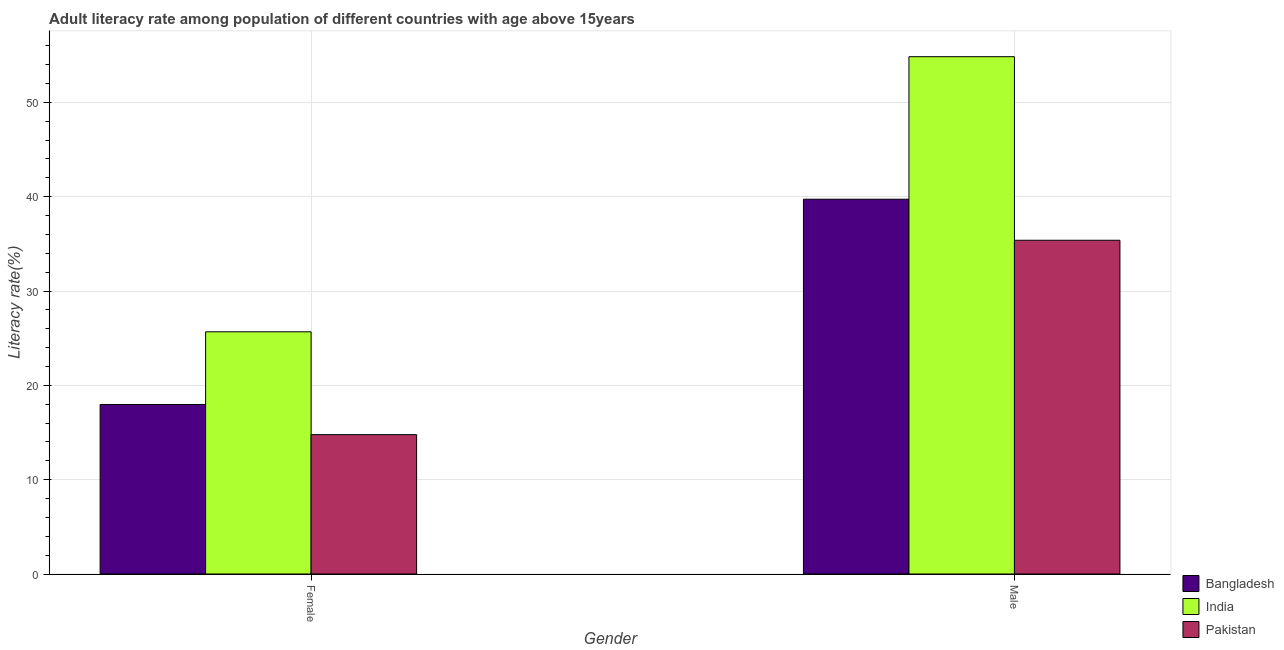How many different coloured bars are there?
Your answer should be compact. 3. How many groups of bars are there?
Your answer should be compact. 2. How many bars are there on the 1st tick from the right?
Your response must be concise. 3. What is the label of the 1st group of bars from the left?
Give a very brief answer. Female. What is the female adult literacy rate in Bangladesh?
Give a very brief answer. 17.97. Across all countries, what is the maximum male adult literacy rate?
Your answer should be compact. 54.84. Across all countries, what is the minimum female adult literacy rate?
Your answer should be very brief. 14.77. In which country was the female adult literacy rate maximum?
Offer a terse response. India. In which country was the female adult literacy rate minimum?
Provide a succinct answer. Pakistan. What is the total female adult literacy rate in the graph?
Your answer should be very brief. 58.42. What is the difference between the male adult literacy rate in Bangladesh and that in Pakistan?
Ensure brevity in your answer.  4.35. What is the difference between the male adult literacy rate in Pakistan and the female adult literacy rate in India?
Your answer should be compact. 9.7. What is the average female adult literacy rate per country?
Give a very brief answer. 19.47. What is the difference between the male adult literacy rate and female adult literacy rate in Bangladesh?
Offer a terse response. 21.76. In how many countries, is the female adult literacy rate greater than 18 %?
Your answer should be very brief. 1. What is the ratio of the female adult literacy rate in Bangladesh to that in Pakistan?
Your answer should be compact. 1.22. In how many countries, is the female adult literacy rate greater than the average female adult literacy rate taken over all countries?
Make the answer very short. 1. What does the 2nd bar from the left in Male represents?
Provide a succinct answer. India. What does the 1st bar from the right in Male represents?
Your answer should be very brief. Pakistan. Are all the bars in the graph horizontal?
Your answer should be very brief. No. Does the graph contain any zero values?
Your answer should be very brief. No. Where does the legend appear in the graph?
Your answer should be very brief. Bottom right. How are the legend labels stacked?
Ensure brevity in your answer.  Vertical. What is the title of the graph?
Provide a short and direct response. Adult literacy rate among population of different countries with age above 15years. Does "Sub-Saharan Africa (all income levels)" appear as one of the legend labels in the graph?
Offer a very short reply. No. What is the label or title of the Y-axis?
Your answer should be very brief. Literacy rate(%). What is the Literacy rate(%) of Bangladesh in Female?
Make the answer very short. 17.97. What is the Literacy rate(%) in India in Female?
Offer a very short reply. 25.68. What is the Literacy rate(%) of Pakistan in Female?
Provide a succinct answer. 14.77. What is the Literacy rate(%) of Bangladesh in Male?
Your answer should be very brief. 39.73. What is the Literacy rate(%) of India in Male?
Your answer should be compact. 54.84. What is the Literacy rate(%) of Pakistan in Male?
Provide a short and direct response. 35.38. Across all Gender, what is the maximum Literacy rate(%) of Bangladesh?
Ensure brevity in your answer.  39.73. Across all Gender, what is the maximum Literacy rate(%) in India?
Keep it short and to the point. 54.84. Across all Gender, what is the maximum Literacy rate(%) of Pakistan?
Offer a very short reply. 35.38. Across all Gender, what is the minimum Literacy rate(%) of Bangladesh?
Offer a very short reply. 17.97. Across all Gender, what is the minimum Literacy rate(%) in India?
Give a very brief answer. 25.68. Across all Gender, what is the minimum Literacy rate(%) of Pakistan?
Provide a short and direct response. 14.77. What is the total Literacy rate(%) of Bangladesh in the graph?
Make the answer very short. 57.7. What is the total Literacy rate(%) of India in the graph?
Offer a very short reply. 80.52. What is the total Literacy rate(%) of Pakistan in the graph?
Give a very brief answer. 50.15. What is the difference between the Literacy rate(%) in Bangladesh in Female and that in Male?
Ensure brevity in your answer.  -21.76. What is the difference between the Literacy rate(%) of India in Female and that in Male?
Keep it short and to the point. -29.16. What is the difference between the Literacy rate(%) of Pakistan in Female and that in Male?
Make the answer very short. -20.61. What is the difference between the Literacy rate(%) in Bangladesh in Female and the Literacy rate(%) in India in Male?
Your answer should be compact. -36.87. What is the difference between the Literacy rate(%) of Bangladesh in Female and the Literacy rate(%) of Pakistan in Male?
Ensure brevity in your answer.  -17.41. What is the difference between the Literacy rate(%) in India in Female and the Literacy rate(%) in Pakistan in Male?
Offer a very short reply. -9.7. What is the average Literacy rate(%) in Bangladesh per Gender?
Your answer should be compact. 28.85. What is the average Literacy rate(%) in India per Gender?
Offer a very short reply. 40.26. What is the average Literacy rate(%) in Pakistan per Gender?
Make the answer very short. 25.08. What is the difference between the Literacy rate(%) of Bangladesh and Literacy rate(%) of India in Female?
Provide a short and direct response. -7.7. What is the difference between the Literacy rate(%) of Bangladesh and Literacy rate(%) of Pakistan in Female?
Your response must be concise. 3.2. What is the difference between the Literacy rate(%) of India and Literacy rate(%) of Pakistan in Female?
Your response must be concise. 10.9. What is the difference between the Literacy rate(%) of Bangladesh and Literacy rate(%) of India in Male?
Provide a short and direct response. -15.11. What is the difference between the Literacy rate(%) in Bangladesh and Literacy rate(%) in Pakistan in Male?
Your response must be concise. 4.35. What is the difference between the Literacy rate(%) in India and Literacy rate(%) in Pakistan in Male?
Keep it short and to the point. 19.46. What is the ratio of the Literacy rate(%) in Bangladesh in Female to that in Male?
Give a very brief answer. 0.45. What is the ratio of the Literacy rate(%) of India in Female to that in Male?
Your answer should be compact. 0.47. What is the ratio of the Literacy rate(%) of Pakistan in Female to that in Male?
Ensure brevity in your answer.  0.42. What is the difference between the highest and the second highest Literacy rate(%) of Bangladesh?
Keep it short and to the point. 21.76. What is the difference between the highest and the second highest Literacy rate(%) in India?
Your response must be concise. 29.16. What is the difference between the highest and the second highest Literacy rate(%) in Pakistan?
Make the answer very short. 20.61. What is the difference between the highest and the lowest Literacy rate(%) in Bangladesh?
Provide a succinct answer. 21.76. What is the difference between the highest and the lowest Literacy rate(%) in India?
Make the answer very short. 29.16. What is the difference between the highest and the lowest Literacy rate(%) of Pakistan?
Give a very brief answer. 20.61. 